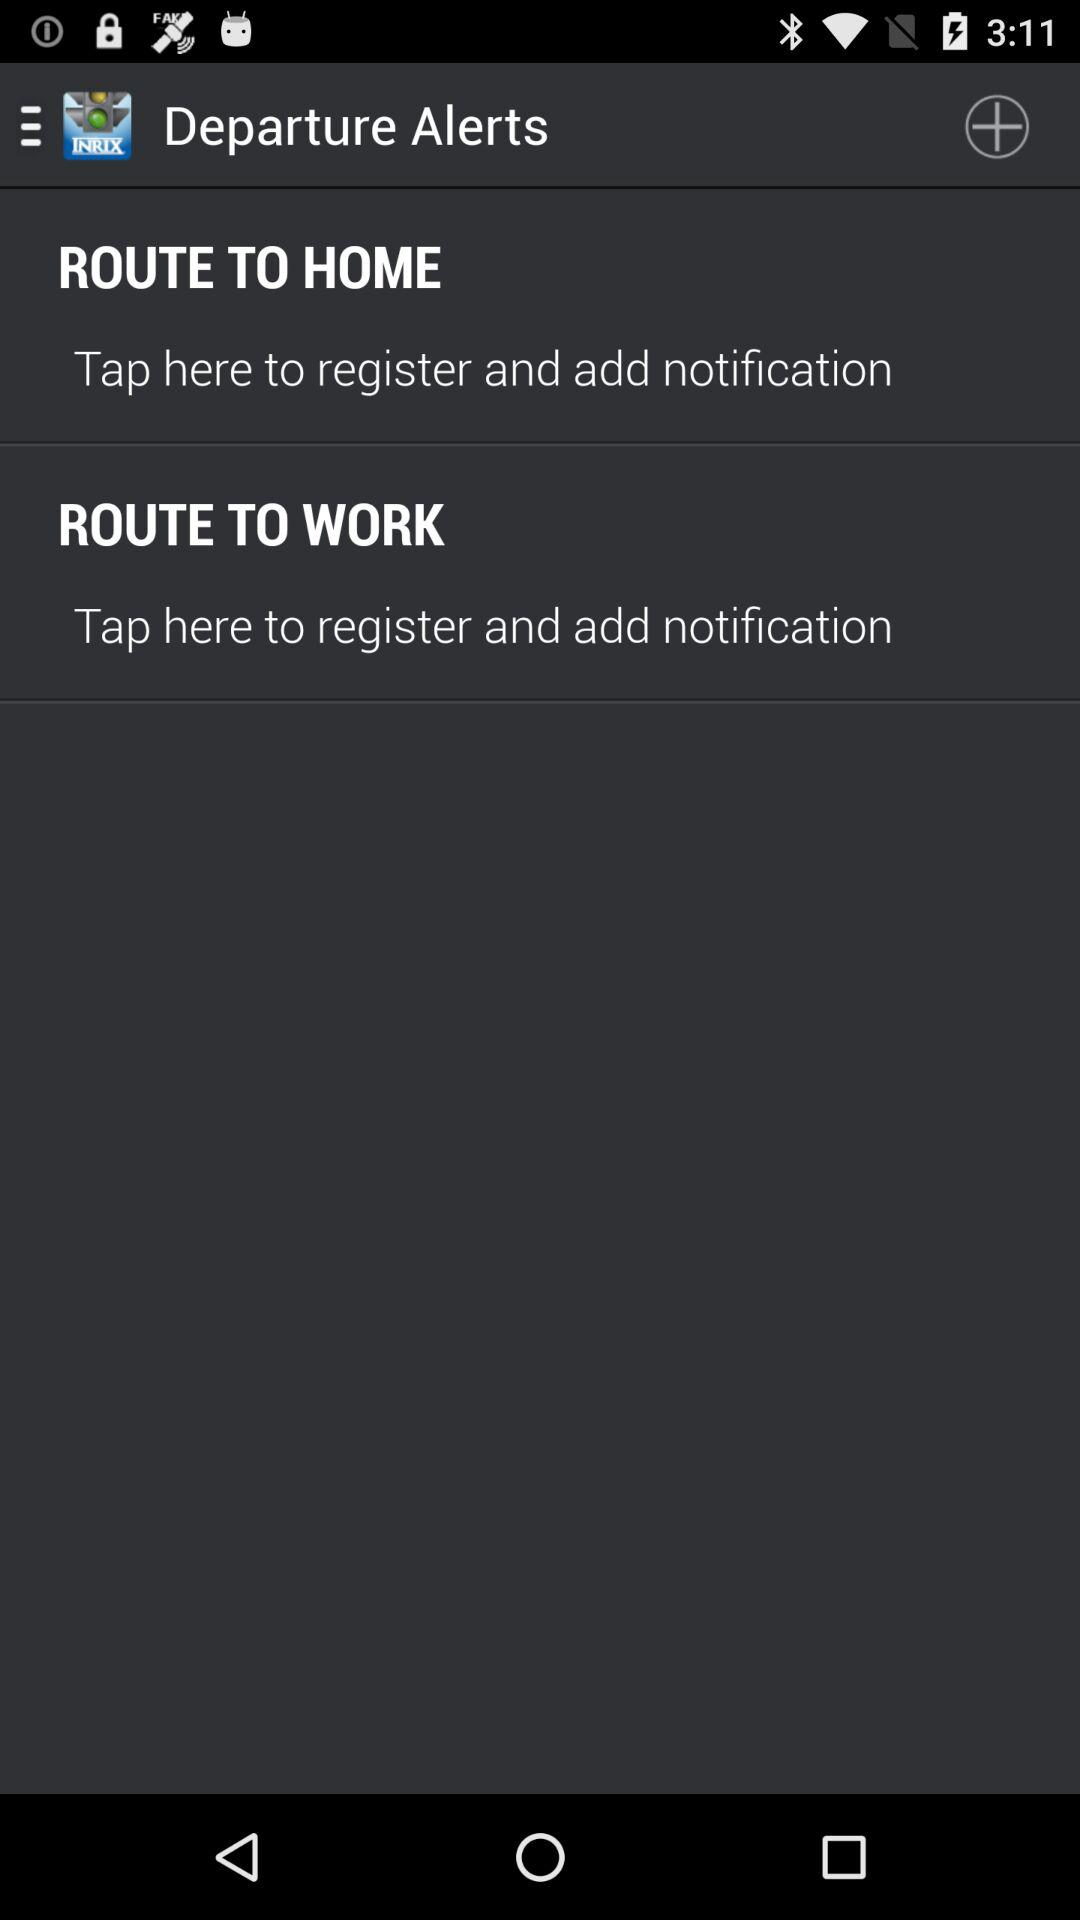How many more routes are there than departure alerts?
Answer the question using a single word or phrase. 2 